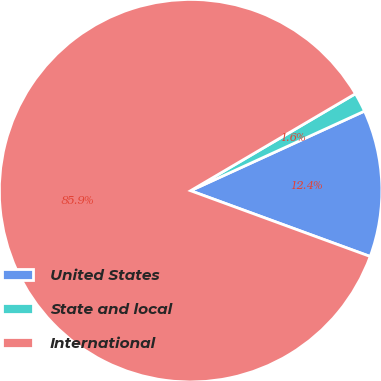Convert chart. <chart><loc_0><loc_0><loc_500><loc_500><pie_chart><fcel>United States<fcel>State and local<fcel>International<nl><fcel>12.42%<fcel>1.63%<fcel>85.95%<nl></chart> 